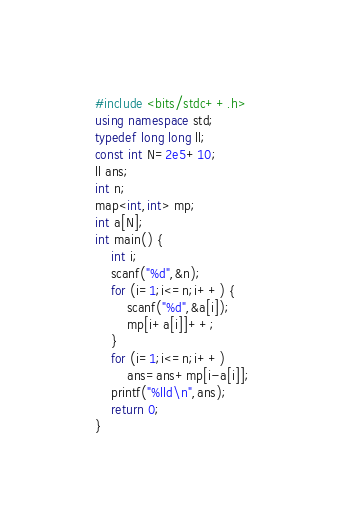<code> <loc_0><loc_0><loc_500><loc_500><_C++_>#include <bits/stdc++.h>
using namespace std;
typedef long long ll;
const int N=2e5+10;
ll ans;
int n;
map<int,int> mp;
int a[N];
int main() {
	int i;
	scanf("%d",&n);
	for (i=1;i<=n;i++) {
		scanf("%d",&a[i]);
		mp[i+a[i]]++;
	}
	for (i=1;i<=n;i++)
		ans=ans+mp[i-a[i]];
	printf("%lld\n",ans);
	return 0;
}</code> 